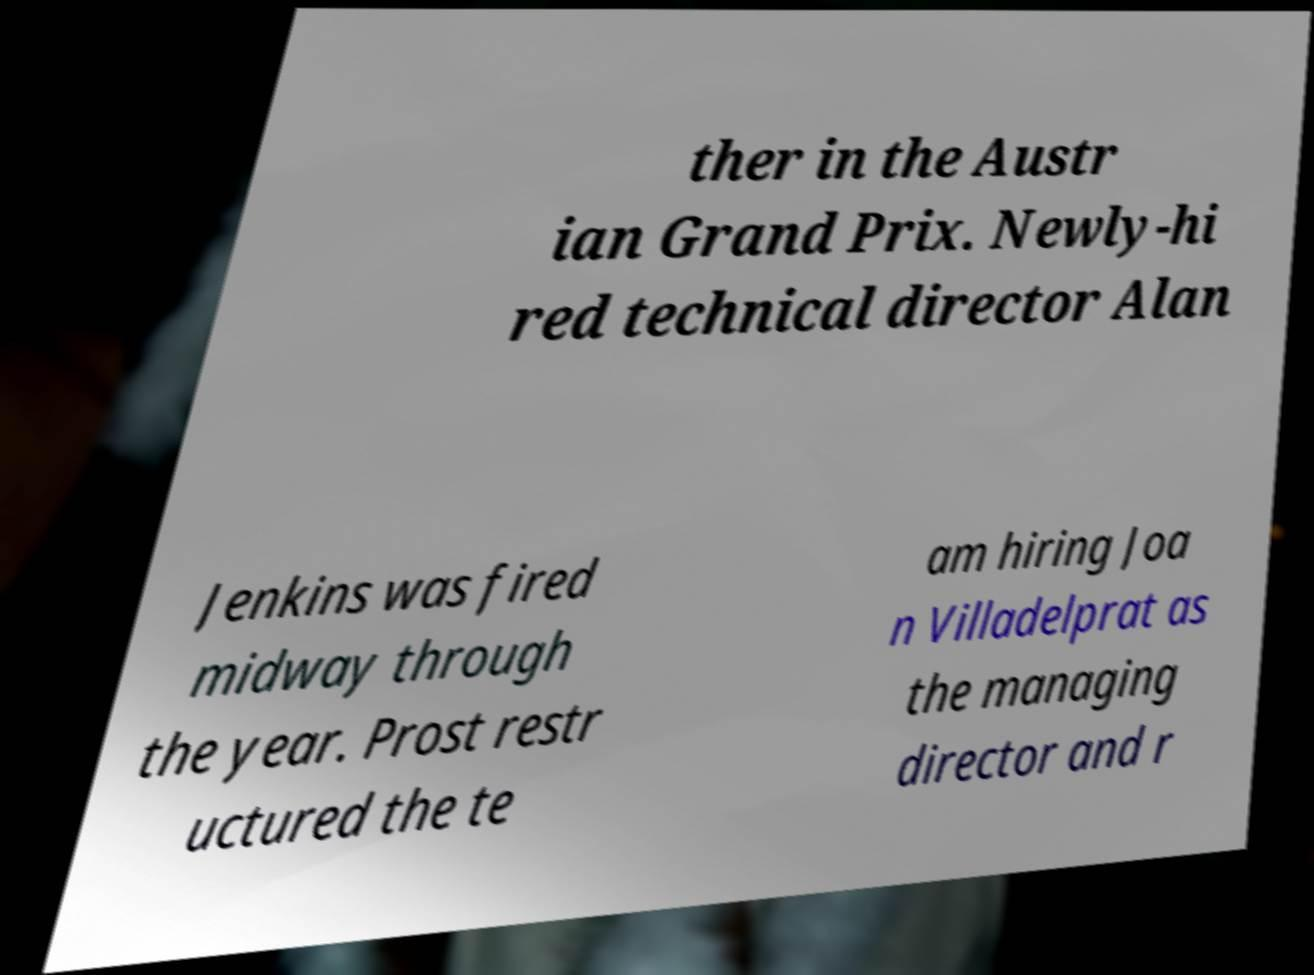There's text embedded in this image that I need extracted. Can you transcribe it verbatim? ther in the Austr ian Grand Prix. Newly-hi red technical director Alan Jenkins was fired midway through the year. Prost restr uctured the te am hiring Joa n Villadelprat as the managing director and r 